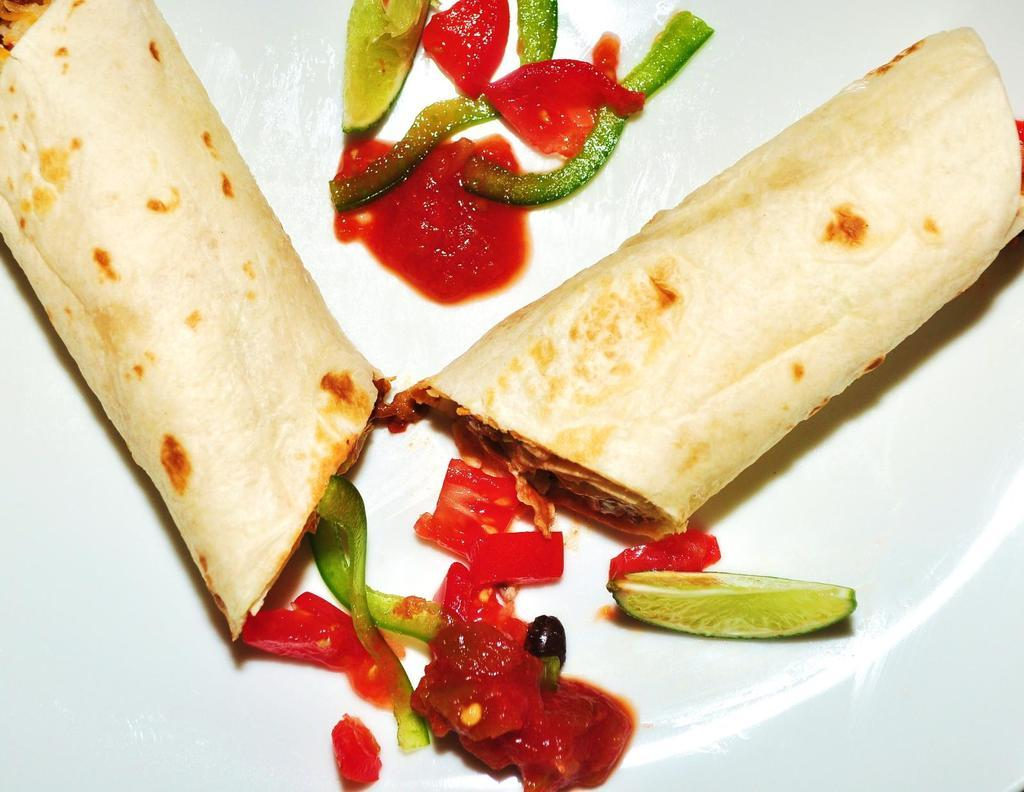What is placed on a plate in the image? There is food placed on a plate in the image. What type of brush is used to show respect in the image? There is no brush or indication of respect present in the image; it only features food placed on a plate. 